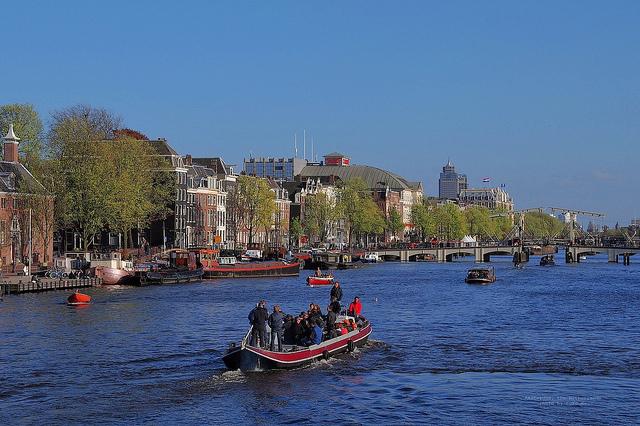How many trees are in the picture?
Give a very brief answer. 13. Is the boat moving?
Write a very short answer. Yes. Is the boat moving towards the camera?
Concise answer only. No. Are there any birds?
Answer briefly. No. 